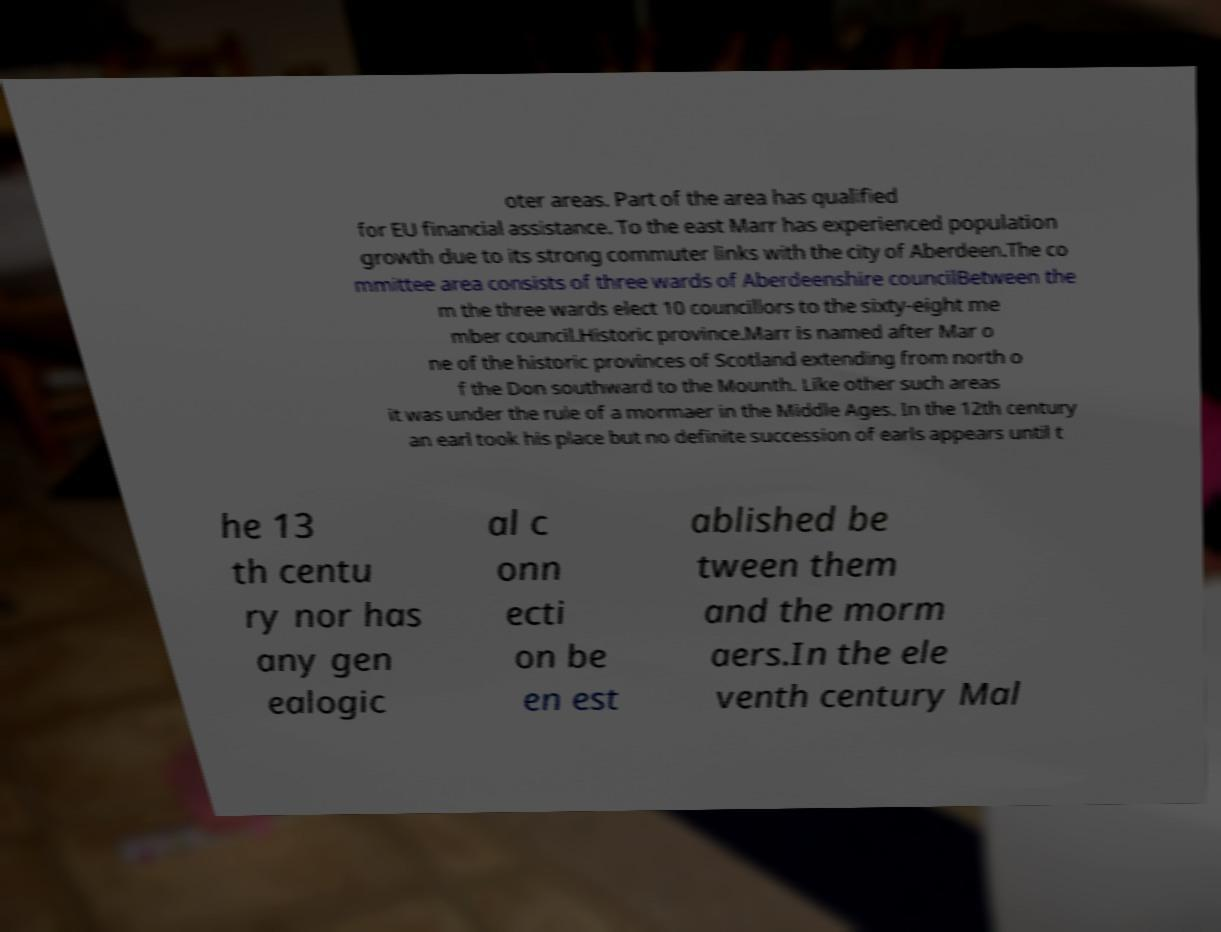For documentation purposes, I need the text within this image transcribed. Could you provide that? oter areas. Part of the area has qualified for EU financial assistance. To the east Marr has experienced population growth due to its strong commuter links with the city of Aberdeen.The co mmittee area consists of three wards of Aberdeenshire councilBetween the m the three wards elect 10 councillors to the sixty-eight me mber council.Historic province.Marr is named after Mar o ne of the historic provinces of Scotland extending from north o f the Don southward to the Mounth. Like other such areas it was under the rule of a mormaer in the Middle Ages. In the 12th century an earl took his place but no definite succession of earls appears until t he 13 th centu ry nor has any gen ealogic al c onn ecti on be en est ablished be tween them and the morm aers.In the ele venth century Mal 